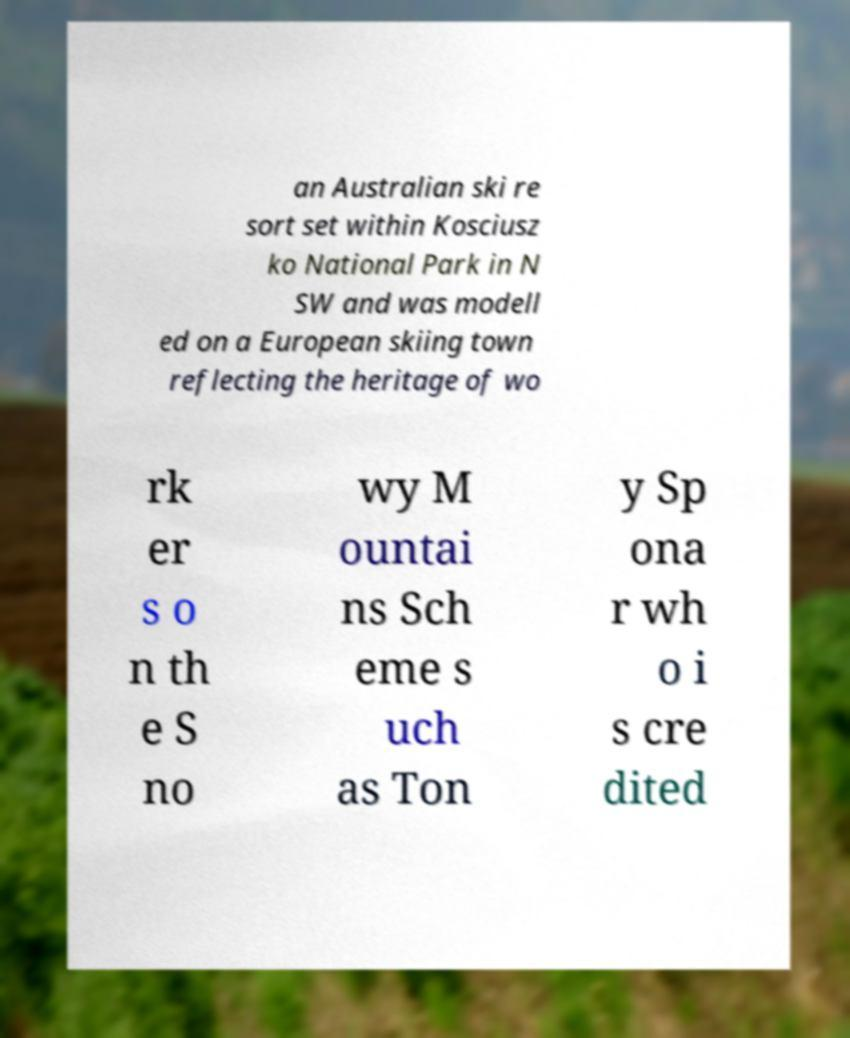I need the written content from this picture converted into text. Can you do that? an Australian ski re sort set within Kosciusz ko National Park in N SW and was modell ed on a European skiing town reflecting the heritage of wo rk er s o n th e S no wy M ountai ns Sch eme s uch as Ton y Sp ona r wh o i s cre dited 